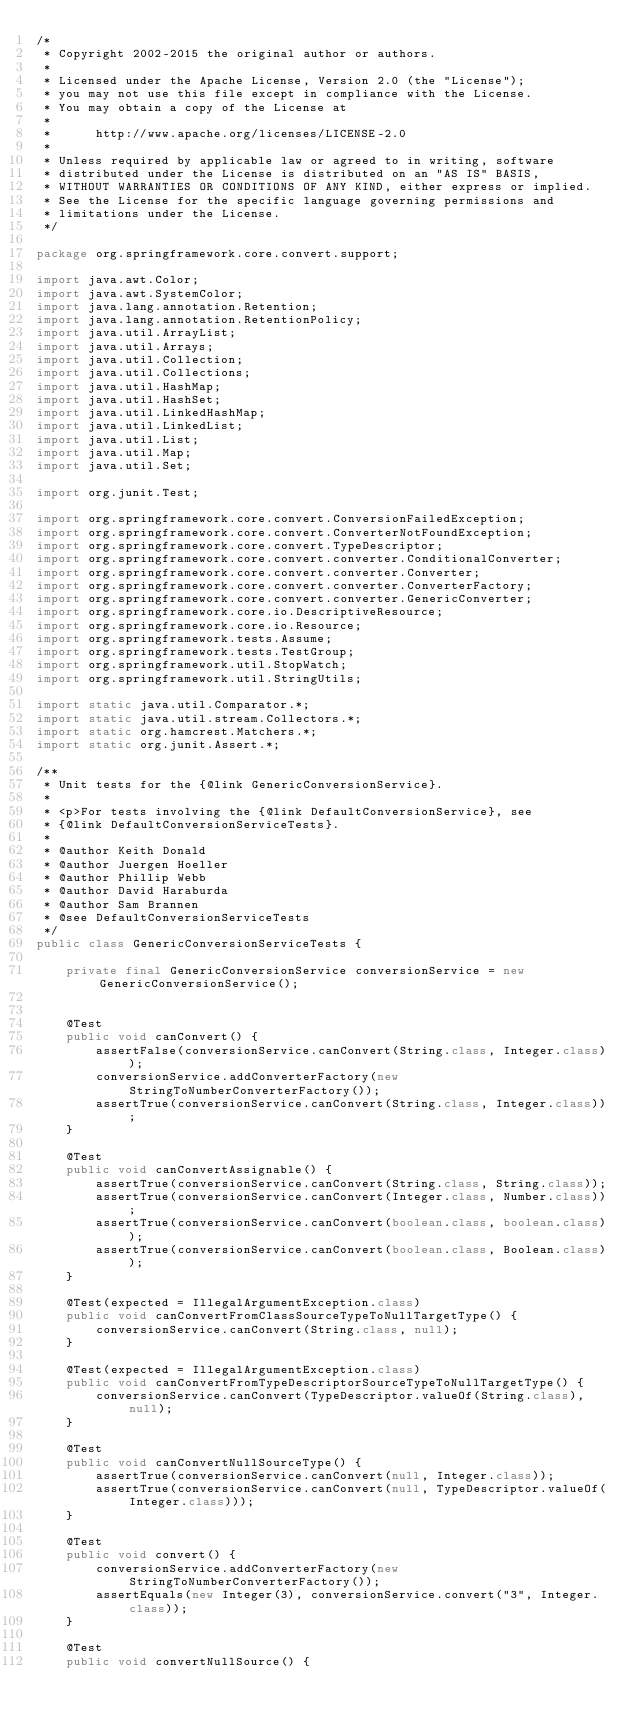Convert code to text. <code><loc_0><loc_0><loc_500><loc_500><_Java_>/*
 * Copyright 2002-2015 the original author or authors.
 *
 * Licensed under the Apache License, Version 2.0 (the "License");
 * you may not use this file except in compliance with the License.
 * You may obtain a copy of the License at
 *
 *      http://www.apache.org/licenses/LICENSE-2.0
 *
 * Unless required by applicable law or agreed to in writing, software
 * distributed under the License is distributed on an "AS IS" BASIS,
 * WITHOUT WARRANTIES OR CONDITIONS OF ANY KIND, either express or implied.
 * See the License for the specific language governing permissions and
 * limitations under the License.
 */

package org.springframework.core.convert.support;

import java.awt.Color;
import java.awt.SystemColor;
import java.lang.annotation.Retention;
import java.lang.annotation.RetentionPolicy;
import java.util.ArrayList;
import java.util.Arrays;
import java.util.Collection;
import java.util.Collections;
import java.util.HashMap;
import java.util.HashSet;
import java.util.LinkedHashMap;
import java.util.LinkedList;
import java.util.List;
import java.util.Map;
import java.util.Set;

import org.junit.Test;

import org.springframework.core.convert.ConversionFailedException;
import org.springframework.core.convert.ConverterNotFoundException;
import org.springframework.core.convert.TypeDescriptor;
import org.springframework.core.convert.converter.ConditionalConverter;
import org.springframework.core.convert.converter.Converter;
import org.springframework.core.convert.converter.ConverterFactory;
import org.springframework.core.convert.converter.GenericConverter;
import org.springframework.core.io.DescriptiveResource;
import org.springframework.core.io.Resource;
import org.springframework.tests.Assume;
import org.springframework.tests.TestGroup;
import org.springframework.util.StopWatch;
import org.springframework.util.StringUtils;

import static java.util.Comparator.*;
import static java.util.stream.Collectors.*;
import static org.hamcrest.Matchers.*;
import static org.junit.Assert.*;

/**
 * Unit tests for the {@link GenericConversionService}.
 *
 * <p>For tests involving the {@link DefaultConversionService}, see 
 * {@link DefaultConversionServiceTests}.
 *
 * @author Keith Donald
 * @author Juergen Hoeller
 * @author Phillip Webb
 * @author David Haraburda
 * @author Sam Brannen
 * @see DefaultConversionServiceTests
 */
public class GenericConversionServiceTests {

	private final GenericConversionService conversionService = new GenericConversionService();


	@Test
	public void canConvert() {
		assertFalse(conversionService.canConvert(String.class, Integer.class));
		conversionService.addConverterFactory(new StringToNumberConverterFactory());
		assertTrue(conversionService.canConvert(String.class, Integer.class));
	}

	@Test
	public void canConvertAssignable() {
		assertTrue(conversionService.canConvert(String.class, String.class));
		assertTrue(conversionService.canConvert(Integer.class, Number.class));
		assertTrue(conversionService.canConvert(boolean.class, boolean.class));
		assertTrue(conversionService.canConvert(boolean.class, Boolean.class));
	}

	@Test(expected = IllegalArgumentException.class)
	public void canConvertFromClassSourceTypeToNullTargetType() {
		conversionService.canConvert(String.class, null);
	}

	@Test(expected = IllegalArgumentException.class)
	public void canConvertFromTypeDescriptorSourceTypeToNullTargetType() {
		conversionService.canConvert(TypeDescriptor.valueOf(String.class), null);
	}

	@Test
	public void canConvertNullSourceType() {
		assertTrue(conversionService.canConvert(null, Integer.class));
		assertTrue(conversionService.canConvert(null, TypeDescriptor.valueOf(Integer.class)));
	}

	@Test
	public void convert() {
		conversionService.addConverterFactory(new StringToNumberConverterFactory());
		assertEquals(new Integer(3), conversionService.convert("3", Integer.class));
	}

	@Test
	public void convertNullSource() {</code> 